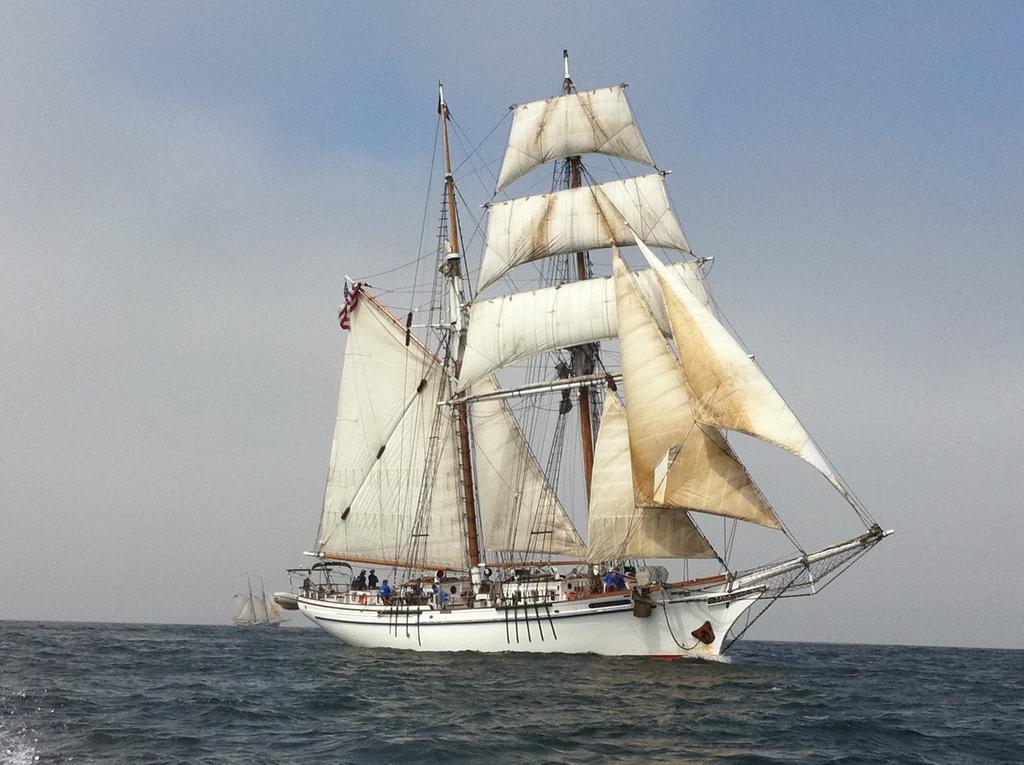How would you summarize this image in a sentence or two? In this picture we can see few ships on the water, and we can find few people in the ship. 